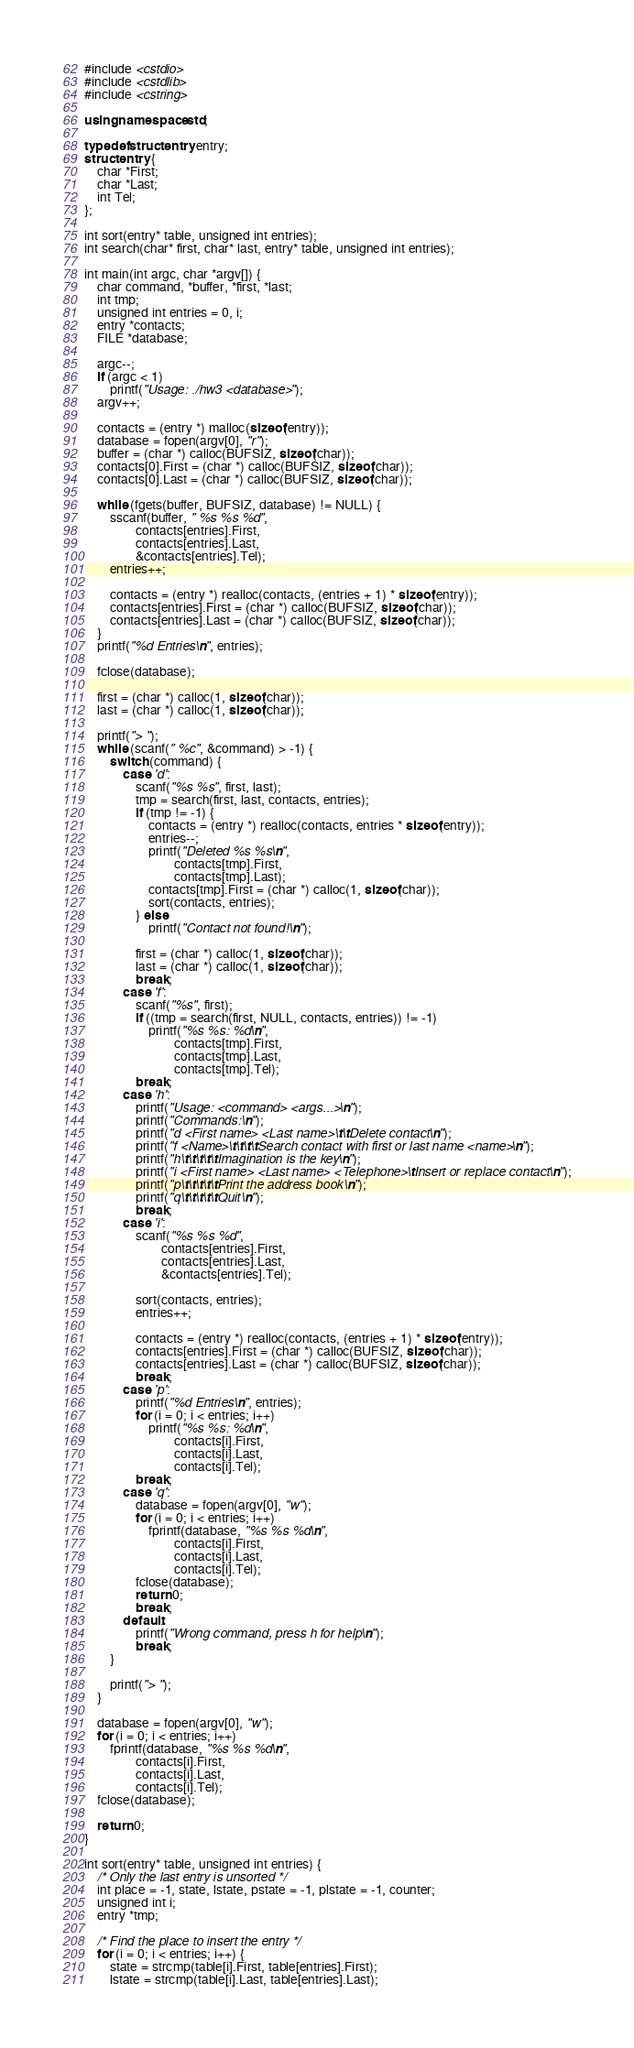<code> <loc_0><loc_0><loc_500><loc_500><_C++_>#include <cstdio>
#include <cstdlib>
#include <cstring>

using namespace std;

typedef struct entry entry;
struct entry {
	char *First;
	char *Last;
	int Tel;
};

int sort(entry* table, unsigned int entries);
int search(char* first, char* last, entry* table, unsigned int entries);

int main(int argc, char *argv[]) {
	char command, *buffer, *first, *last;
	int tmp;
	unsigned int entries = 0, i;
	entry *contacts;
	FILE *database;

	argc--;
	if (argc < 1)
		printf("Usage: ./hw3 <database>");
	argv++;

	contacts = (entry *) malloc(sizeof(entry));
	database = fopen(argv[0], "r");
	buffer = (char *) calloc(BUFSIZ, sizeof(char));
	contacts[0].First = (char *) calloc(BUFSIZ, sizeof(char));
	contacts[0].Last = (char *) calloc(BUFSIZ, sizeof(char));

	while (fgets(buffer, BUFSIZ, database) != NULL) {
		sscanf(buffer, " %s %s %d",
				contacts[entries].First,
				contacts[entries].Last,
				&contacts[entries].Tel);
		entries++;

		contacts = (entry *) realloc(contacts, (entries + 1) * sizeof(entry));
		contacts[entries].First = (char *) calloc(BUFSIZ, sizeof(char));
		contacts[entries].Last = (char *) calloc(BUFSIZ, sizeof(char));
	}
	printf("%d Entries\n", entries);

	fclose(database);

	first = (char *) calloc(1, sizeof(char));
	last = (char *) calloc(1, sizeof(char));

	printf("> ");
	while (scanf(" %c", &command) > -1) {
		switch (command) {
			case 'd':
				scanf("%s %s", first, last);
				tmp = search(first, last, contacts, entries);
				if (tmp != -1) {
					contacts = (entry *) realloc(contacts, entries * sizeof(entry));
					entries--;
					printf("Deleted %s %s\n",
							contacts[tmp].First,
							contacts[tmp].Last);
					contacts[tmp].First = (char *) calloc(1, sizeof(char));
					sort(contacts, entries);
				} else
					printf("Contact not found!\n");

				first = (char *) calloc(1, sizeof(char));
				last = (char *) calloc(1, sizeof(char));
				break;
			case 'f':
				scanf("%s", first);
				if ((tmp = search(first, NULL, contacts, entries)) != -1)
					printf("%s %s: %d\n",
							contacts[tmp].First,
							contacts[tmp].Last,
							contacts[tmp].Tel);
				break;
			case 'h':
				printf("Usage: <command> <args...>\n");
				printf("Commands:\n");
				printf("d <First name> <Last name>\t\tDelete contact\n");
				printf("f <Name>\t\t\t\tSearch contact with first or last name <name>\n");
				printf("h\t\t\t\t\tImagination is the key\n");
				printf("i <First name> <Last name> <Telephone>\tInsert or replace contact\n");
				printf("p\t\t\t\t\tPrint the address book\n");
				printf("q\t\t\t\t\tQuit\n");
				break;
			case 'i':
				scanf("%s %s %d",
						contacts[entries].First,
						contacts[entries].Last,
						&contacts[entries].Tel);

				sort(contacts, entries);
				entries++;

				contacts = (entry *) realloc(contacts, (entries + 1) * sizeof(entry));
				contacts[entries].First = (char *) calloc(BUFSIZ, sizeof(char));
				contacts[entries].Last = (char *) calloc(BUFSIZ, sizeof(char));
				break;
			case 'p':
				printf("%d Entries\n", entries);
				for (i = 0; i < entries; i++)
					printf("%s %s: %d\n",
							contacts[i].First,
							contacts[i].Last,
							contacts[i].Tel);
				break;
			case 'q':
				database = fopen(argv[0], "w");
				for (i = 0; i < entries; i++)
					fprintf(database, "%s %s %d\n",
							contacts[i].First,
							contacts[i].Last,
							contacts[i].Tel);
				fclose(database);
				return 0;
				break;
			default:
				printf("Wrong command, press h for help\n");
				break;
		}

		printf("> ");
	}

	database = fopen(argv[0], "w");
	for (i = 0; i < entries; i++)
		fprintf(database, "%s %s %d\n",
				contacts[i].First,
				contacts[i].Last,
				contacts[i].Tel);
	fclose(database);

	return 0;
}

int sort(entry* table, unsigned int entries) {
	/* Only the last entry is unsorted */
	int place = -1, state, lstate, pstate = -1, plstate = -1, counter;
	unsigned int i;
	entry *tmp;

	/* Find the place to insert the entry */
	for (i = 0; i < entries; i++) {
		state = strcmp(table[i].First, table[entries].First);
		lstate = strcmp(table[i].Last, table[entries].Last);</code> 